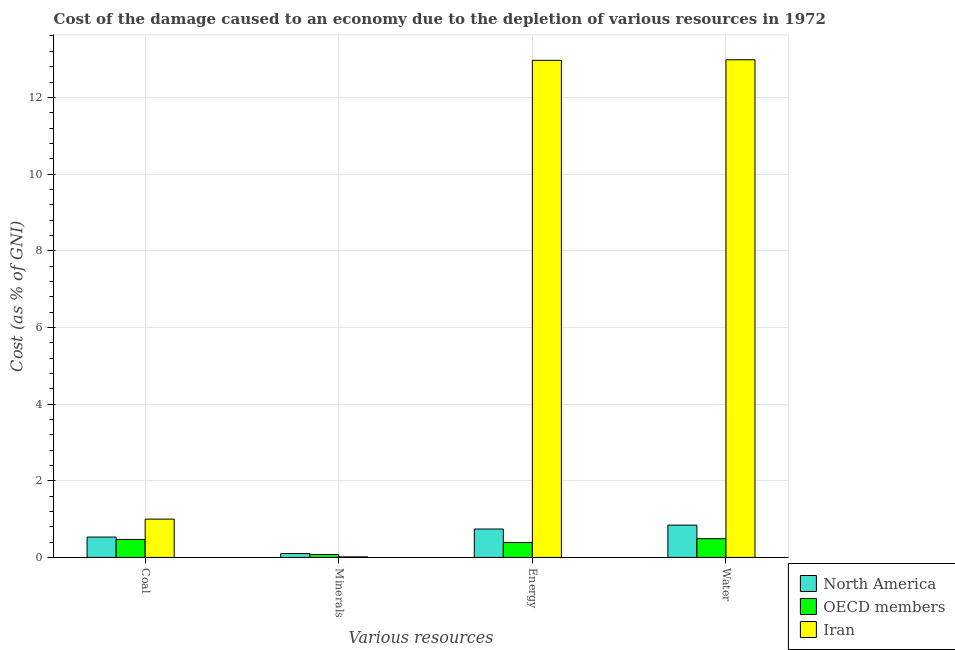How many different coloured bars are there?
Make the answer very short. 3. How many groups of bars are there?
Your answer should be very brief. 4. Are the number of bars per tick equal to the number of legend labels?
Offer a terse response. Yes. Are the number of bars on each tick of the X-axis equal?
Provide a succinct answer. Yes. How many bars are there on the 3rd tick from the left?
Give a very brief answer. 3. What is the label of the 2nd group of bars from the left?
Offer a very short reply. Minerals. What is the cost of damage due to depletion of coal in North America?
Your response must be concise. 0.53. Across all countries, what is the maximum cost of damage due to depletion of coal?
Offer a very short reply. 1. Across all countries, what is the minimum cost of damage due to depletion of energy?
Your response must be concise. 0.39. In which country was the cost of damage due to depletion of energy maximum?
Offer a very short reply. Iran. In which country was the cost of damage due to depletion of energy minimum?
Make the answer very short. OECD members. What is the total cost of damage due to depletion of minerals in the graph?
Make the answer very short. 0.19. What is the difference between the cost of damage due to depletion of water in North America and that in Iran?
Provide a short and direct response. -12.14. What is the difference between the cost of damage due to depletion of coal in North America and the cost of damage due to depletion of energy in Iran?
Provide a short and direct response. -12.43. What is the average cost of damage due to depletion of water per country?
Your response must be concise. 4.77. What is the difference between the cost of damage due to depletion of coal and cost of damage due to depletion of water in OECD members?
Give a very brief answer. -0.02. What is the ratio of the cost of damage due to depletion of energy in Iran to that in OECD members?
Your response must be concise. 33.41. Is the cost of damage due to depletion of water in OECD members less than that in Iran?
Ensure brevity in your answer.  Yes. Is the difference between the cost of damage due to depletion of minerals in Iran and North America greater than the difference between the cost of damage due to depletion of coal in Iran and North America?
Ensure brevity in your answer.  No. What is the difference between the highest and the second highest cost of damage due to depletion of water?
Offer a terse response. 12.14. What is the difference between the highest and the lowest cost of damage due to depletion of water?
Give a very brief answer. 12.49. In how many countries, is the cost of damage due to depletion of coal greater than the average cost of damage due to depletion of coal taken over all countries?
Provide a short and direct response. 1. Is the sum of the cost of damage due to depletion of minerals in North America and Iran greater than the maximum cost of damage due to depletion of energy across all countries?
Make the answer very short. No. Is it the case that in every country, the sum of the cost of damage due to depletion of energy and cost of damage due to depletion of coal is greater than the sum of cost of damage due to depletion of water and cost of damage due to depletion of minerals?
Give a very brief answer. No. What does the 3rd bar from the left in Water represents?
Provide a short and direct response. Iran. What does the 1st bar from the right in Energy represents?
Provide a short and direct response. Iran. How many countries are there in the graph?
Ensure brevity in your answer.  3. Does the graph contain grids?
Keep it short and to the point. Yes. How many legend labels are there?
Your answer should be compact. 3. What is the title of the graph?
Offer a very short reply. Cost of the damage caused to an economy due to the depletion of various resources in 1972 . Does "Guinea-Bissau" appear as one of the legend labels in the graph?
Provide a short and direct response. No. What is the label or title of the X-axis?
Make the answer very short. Various resources. What is the label or title of the Y-axis?
Ensure brevity in your answer.  Cost (as % of GNI). What is the Cost (as % of GNI) of North America in Coal?
Your answer should be compact. 0.53. What is the Cost (as % of GNI) of OECD members in Coal?
Offer a very short reply. 0.47. What is the Cost (as % of GNI) of Iran in Coal?
Give a very brief answer. 1. What is the Cost (as % of GNI) of North America in Minerals?
Offer a terse response. 0.1. What is the Cost (as % of GNI) of OECD members in Minerals?
Give a very brief answer. 0.08. What is the Cost (as % of GNI) of Iran in Minerals?
Keep it short and to the point. 0.02. What is the Cost (as % of GNI) in North America in Energy?
Offer a terse response. 0.74. What is the Cost (as % of GNI) in OECD members in Energy?
Provide a succinct answer. 0.39. What is the Cost (as % of GNI) of Iran in Energy?
Offer a very short reply. 12.97. What is the Cost (as % of GNI) in North America in Water?
Provide a succinct answer. 0.84. What is the Cost (as % of GNI) of OECD members in Water?
Offer a terse response. 0.49. What is the Cost (as % of GNI) in Iran in Water?
Keep it short and to the point. 12.98. Across all Various resources, what is the maximum Cost (as % of GNI) in North America?
Your answer should be compact. 0.84. Across all Various resources, what is the maximum Cost (as % of GNI) of OECD members?
Your response must be concise. 0.49. Across all Various resources, what is the maximum Cost (as % of GNI) of Iran?
Give a very brief answer. 12.98. Across all Various resources, what is the minimum Cost (as % of GNI) in North America?
Give a very brief answer. 0.1. Across all Various resources, what is the minimum Cost (as % of GNI) in OECD members?
Offer a terse response. 0.08. Across all Various resources, what is the minimum Cost (as % of GNI) of Iran?
Make the answer very short. 0.02. What is the total Cost (as % of GNI) in North America in the graph?
Ensure brevity in your answer.  2.22. What is the total Cost (as % of GNI) of OECD members in the graph?
Give a very brief answer. 1.42. What is the total Cost (as % of GNI) of Iran in the graph?
Provide a succinct answer. 26.96. What is the difference between the Cost (as % of GNI) in North America in Coal and that in Minerals?
Your answer should be very brief. 0.43. What is the difference between the Cost (as % of GNI) in OECD members in Coal and that in Minerals?
Provide a short and direct response. 0.39. What is the difference between the Cost (as % of GNI) in Iran in Coal and that in Minerals?
Your answer should be compact. 0.98. What is the difference between the Cost (as % of GNI) in North America in Coal and that in Energy?
Make the answer very short. -0.21. What is the difference between the Cost (as % of GNI) of OECD members in Coal and that in Energy?
Provide a succinct answer. 0.08. What is the difference between the Cost (as % of GNI) in Iran in Coal and that in Energy?
Ensure brevity in your answer.  -11.97. What is the difference between the Cost (as % of GNI) of North America in Coal and that in Water?
Your response must be concise. -0.31. What is the difference between the Cost (as % of GNI) of OECD members in Coal and that in Water?
Offer a very short reply. -0.02. What is the difference between the Cost (as % of GNI) in Iran in Coal and that in Water?
Provide a short and direct response. -11.98. What is the difference between the Cost (as % of GNI) in North America in Minerals and that in Energy?
Provide a succinct answer. -0.64. What is the difference between the Cost (as % of GNI) in OECD members in Minerals and that in Energy?
Provide a short and direct response. -0.31. What is the difference between the Cost (as % of GNI) in Iran in Minerals and that in Energy?
Ensure brevity in your answer.  -12.95. What is the difference between the Cost (as % of GNI) in North America in Minerals and that in Water?
Offer a terse response. -0.74. What is the difference between the Cost (as % of GNI) of OECD members in Minerals and that in Water?
Your response must be concise. -0.41. What is the difference between the Cost (as % of GNI) in Iran in Minerals and that in Water?
Give a very brief answer. -12.97. What is the difference between the Cost (as % of GNI) of North America in Energy and that in Water?
Your answer should be compact. -0.1. What is the difference between the Cost (as % of GNI) in OECD members in Energy and that in Water?
Make the answer very short. -0.1. What is the difference between the Cost (as % of GNI) in Iran in Energy and that in Water?
Provide a succinct answer. -0.01. What is the difference between the Cost (as % of GNI) of North America in Coal and the Cost (as % of GNI) of OECD members in Minerals?
Your answer should be very brief. 0.45. What is the difference between the Cost (as % of GNI) in North America in Coal and the Cost (as % of GNI) in Iran in Minerals?
Provide a short and direct response. 0.52. What is the difference between the Cost (as % of GNI) in OECD members in Coal and the Cost (as % of GNI) in Iran in Minerals?
Keep it short and to the point. 0.45. What is the difference between the Cost (as % of GNI) in North America in Coal and the Cost (as % of GNI) in OECD members in Energy?
Offer a terse response. 0.14. What is the difference between the Cost (as % of GNI) of North America in Coal and the Cost (as % of GNI) of Iran in Energy?
Your answer should be very brief. -12.43. What is the difference between the Cost (as % of GNI) of OECD members in Coal and the Cost (as % of GNI) of Iran in Energy?
Provide a succinct answer. -12.5. What is the difference between the Cost (as % of GNI) of North America in Coal and the Cost (as % of GNI) of OECD members in Water?
Keep it short and to the point. 0.04. What is the difference between the Cost (as % of GNI) in North America in Coal and the Cost (as % of GNI) in Iran in Water?
Offer a terse response. -12.45. What is the difference between the Cost (as % of GNI) in OECD members in Coal and the Cost (as % of GNI) in Iran in Water?
Provide a succinct answer. -12.51. What is the difference between the Cost (as % of GNI) in North America in Minerals and the Cost (as % of GNI) in OECD members in Energy?
Keep it short and to the point. -0.29. What is the difference between the Cost (as % of GNI) of North America in Minerals and the Cost (as % of GNI) of Iran in Energy?
Provide a succinct answer. -12.86. What is the difference between the Cost (as % of GNI) of OECD members in Minerals and the Cost (as % of GNI) of Iran in Energy?
Your response must be concise. -12.89. What is the difference between the Cost (as % of GNI) of North America in Minerals and the Cost (as % of GNI) of OECD members in Water?
Provide a short and direct response. -0.39. What is the difference between the Cost (as % of GNI) in North America in Minerals and the Cost (as % of GNI) in Iran in Water?
Offer a very short reply. -12.88. What is the difference between the Cost (as % of GNI) in OECD members in Minerals and the Cost (as % of GNI) in Iran in Water?
Provide a short and direct response. -12.9. What is the difference between the Cost (as % of GNI) in North America in Energy and the Cost (as % of GNI) in OECD members in Water?
Offer a very short reply. 0.25. What is the difference between the Cost (as % of GNI) of North America in Energy and the Cost (as % of GNI) of Iran in Water?
Your response must be concise. -12.24. What is the difference between the Cost (as % of GNI) of OECD members in Energy and the Cost (as % of GNI) of Iran in Water?
Offer a very short reply. -12.59. What is the average Cost (as % of GNI) in North America per Various resources?
Offer a very short reply. 0.55. What is the average Cost (as % of GNI) of OECD members per Various resources?
Provide a short and direct response. 0.36. What is the average Cost (as % of GNI) of Iran per Various resources?
Offer a very short reply. 6.74. What is the difference between the Cost (as % of GNI) in North America and Cost (as % of GNI) in OECD members in Coal?
Your answer should be compact. 0.06. What is the difference between the Cost (as % of GNI) of North America and Cost (as % of GNI) of Iran in Coal?
Your response must be concise. -0.47. What is the difference between the Cost (as % of GNI) of OECD members and Cost (as % of GNI) of Iran in Coal?
Give a very brief answer. -0.53. What is the difference between the Cost (as % of GNI) in North America and Cost (as % of GNI) in OECD members in Minerals?
Provide a short and direct response. 0.02. What is the difference between the Cost (as % of GNI) of North America and Cost (as % of GNI) of Iran in Minerals?
Offer a very short reply. 0.09. What is the difference between the Cost (as % of GNI) of OECD members and Cost (as % of GNI) of Iran in Minerals?
Make the answer very short. 0.06. What is the difference between the Cost (as % of GNI) in North America and Cost (as % of GNI) in OECD members in Energy?
Your answer should be compact. 0.35. What is the difference between the Cost (as % of GNI) of North America and Cost (as % of GNI) of Iran in Energy?
Provide a succinct answer. -12.22. What is the difference between the Cost (as % of GNI) of OECD members and Cost (as % of GNI) of Iran in Energy?
Provide a succinct answer. -12.58. What is the difference between the Cost (as % of GNI) in North America and Cost (as % of GNI) in OECD members in Water?
Make the answer very short. 0.35. What is the difference between the Cost (as % of GNI) in North America and Cost (as % of GNI) in Iran in Water?
Give a very brief answer. -12.14. What is the difference between the Cost (as % of GNI) in OECD members and Cost (as % of GNI) in Iran in Water?
Your response must be concise. -12.49. What is the ratio of the Cost (as % of GNI) of North America in Coal to that in Minerals?
Your answer should be compact. 5.22. What is the ratio of the Cost (as % of GNI) of OECD members in Coal to that in Minerals?
Keep it short and to the point. 6.08. What is the ratio of the Cost (as % of GNI) in Iran in Coal to that in Minerals?
Your answer should be very brief. 66.41. What is the ratio of the Cost (as % of GNI) of North America in Coal to that in Energy?
Your response must be concise. 0.72. What is the ratio of the Cost (as % of GNI) of OECD members in Coal to that in Energy?
Give a very brief answer. 1.21. What is the ratio of the Cost (as % of GNI) of Iran in Coal to that in Energy?
Your answer should be compact. 0.08. What is the ratio of the Cost (as % of GNI) of North America in Coal to that in Water?
Give a very brief answer. 0.63. What is the ratio of the Cost (as % of GNI) of OECD members in Coal to that in Water?
Make the answer very short. 0.96. What is the ratio of the Cost (as % of GNI) in Iran in Coal to that in Water?
Give a very brief answer. 0.08. What is the ratio of the Cost (as % of GNI) of North America in Minerals to that in Energy?
Offer a terse response. 0.14. What is the ratio of the Cost (as % of GNI) of OECD members in Minerals to that in Energy?
Keep it short and to the point. 0.2. What is the ratio of the Cost (as % of GNI) in Iran in Minerals to that in Energy?
Keep it short and to the point. 0. What is the ratio of the Cost (as % of GNI) of North America in Minerals to that in Water?
Your answer should be compact. 0.12. What is the ratio of the Cost (as % of GNI) of OECD members in Minerals to that in Water?
Offer a terse response. 0.16. What is the ratio of the Cost (as % of GNI) of Iran in Minerals to that in Water?
Offer a very short reply. 0. What is the ratio of the Cost (as % of GNI) of North America in Energy to that in Water?
Ensure brevity in your answer.  0.88. What is the ratio of the Cost (as % of GNI) in OECD members in Energy to that in Water?
Make the answer very short. 0.79. What is the difference between the highest and the second highest Cost (as % of GNI) of North America?
Give a very brief answer. 0.1. What is the difference between the highest and the second highest Cost (as % of GNI) of OECD members?
Ensure brevity in your answer.  0.02. What is the difference between the highest and the second highest Cost (as % of GNI) of Iran?
Provide a short and direct response. 0.01. What is the difference between the highest and the lowest Cost (as % of GNI) of North America?
Make the answer very short. 0.74. What is the difference between the highest and the lowest Cost (as % of GNI) of OECD members?
Offer a terse response. 0.41. What is the difference between the highest and the lowest Cost (as % of GNI) of Iran?
Provide a short and direct response. 12.97. 